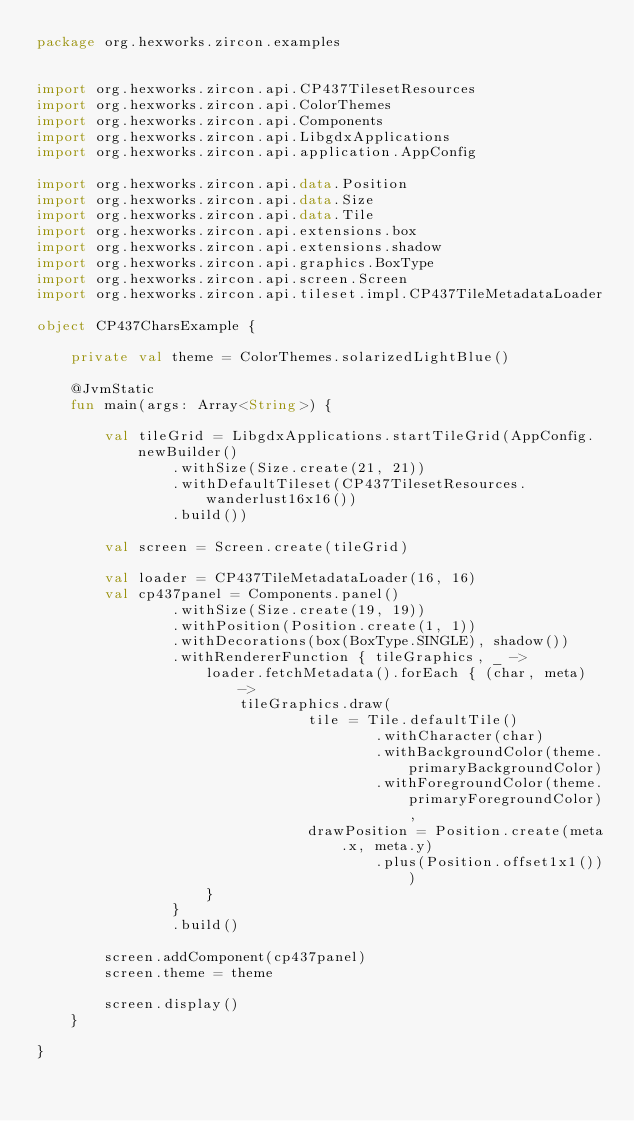<code> <loc_0><loc_0><loc_500><loc_500><_Kotlin_>package org.hexworks.zircon.examples


import org.hexworks.zircon.api.CP437TilesetResources
import org.hexworks.zircon.api.ColorThemes
import org.hexworks.zircon.api.Components
import org.hexworks.zircon.api.LibgdxApplications
import org.hexworks.zircon.api.application.AppConfig

import org.hexworks.zircon.api.data.Position
import org.hexworks.zircon.api.data.Size
import org.hexworks.zircon.api.data.Tile
import org.hexworks.zircon.api.extensions.box
import org.hexworks.zircon.api.extensions.shadow
import org.hexworks.zircon.api.graphics.BoxType
import org.hexworks.zircon.api.screen.Screen
import org.hexworks.zircon.api.tileset.impl.CP437TileMetadataLoader

object CP437CharsExample {

    private val theme = ColorThemes.solarizedLightBlue()

    @JvmStatic
    fun main(args: Array<String>) {

        val tileGrid = LibgdxApplications.startTileGrid(AppConfig.newBuilder()
                .withSize(Size.create(21, 21))
                .withDefaultTileset(CP437TilesetResources.wanderlust16x16())
                .build())

        val screen = Screen.create(tileGrid)

        val loader = CP437TileMetadataLoader(16, 16)
        val cp437panel = Components.panel()
                .withSize(Size.create(19, 19))
                .withPosition(Position.create(1, 1))
                .withDecorations(box(BoxType.SINGLE), shadow())
                .withRendererFunction { tileGraphics, _ ->
                    loader.fetchMetadata().forEach { (char, meta) ->
                        tileGraphics.draw(
                                tile = Tile.defaultTile()
                                        .withCharacter(char)
                                        .withBackgroundColor(theme.primaryBackgroundColor)
                                        .withForegroundColor(theme.primaryForegroundColor),
                                drawPosition = Position.create(meta.x, meta.y)
                                        .plus(Position.offset1x1()))
                    }
                }
                .build()

        screen.addComponent(cp437panel)
        screen.theme = theme

        screen.display()
    }

}
</code> 